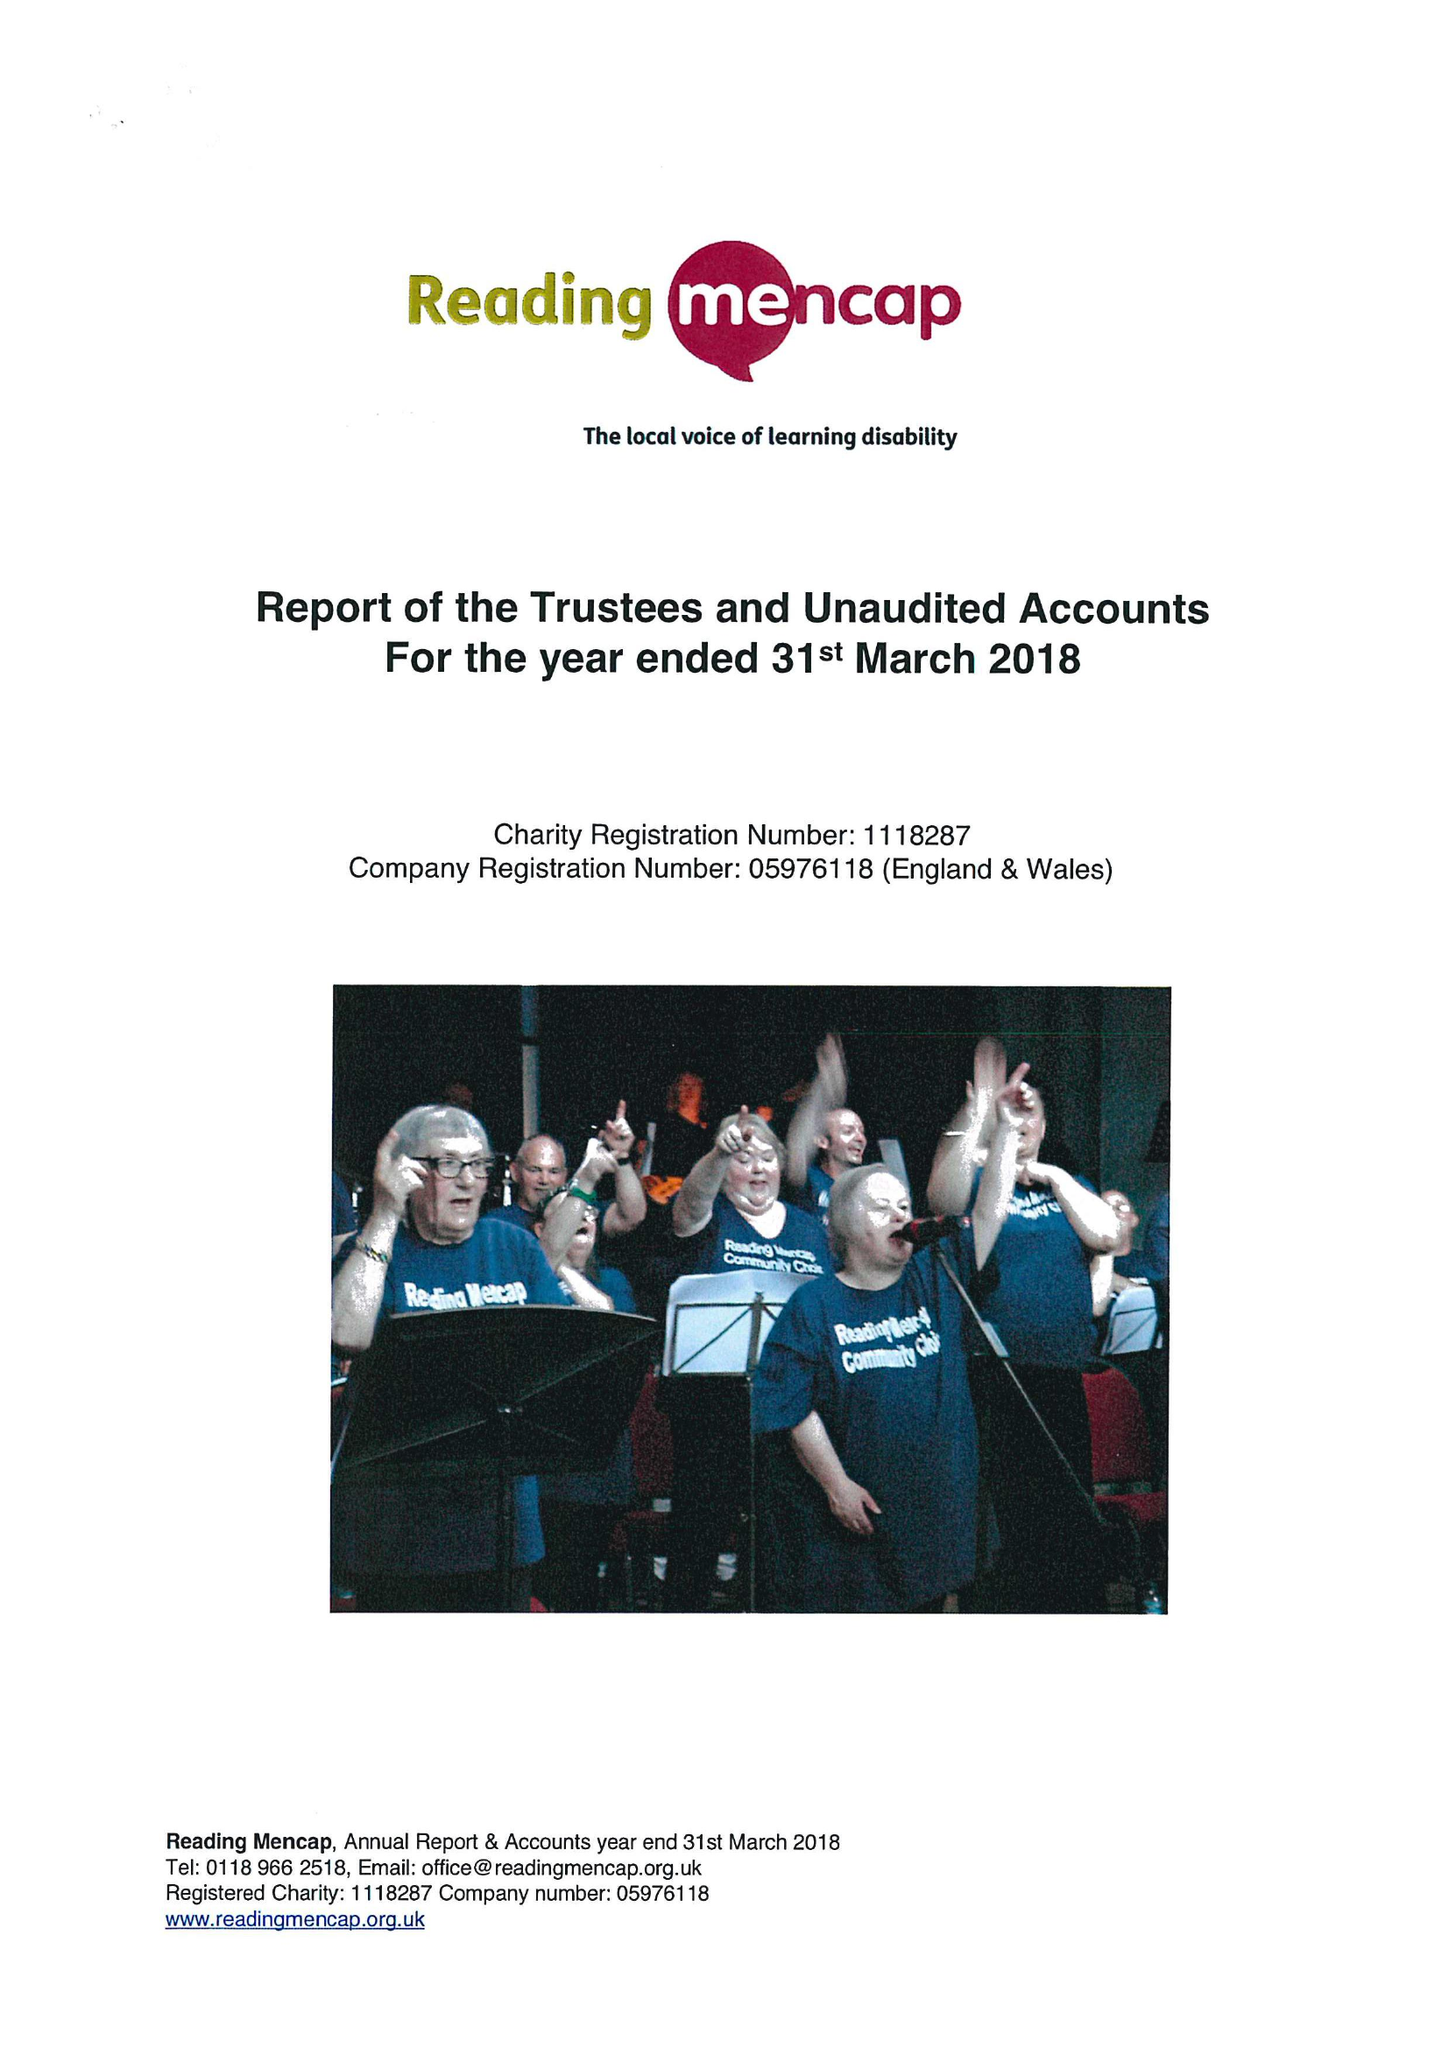What is the value for the spending_annually_in_british_pounds?
Answer the question using a single word or phrase. 359751.00 